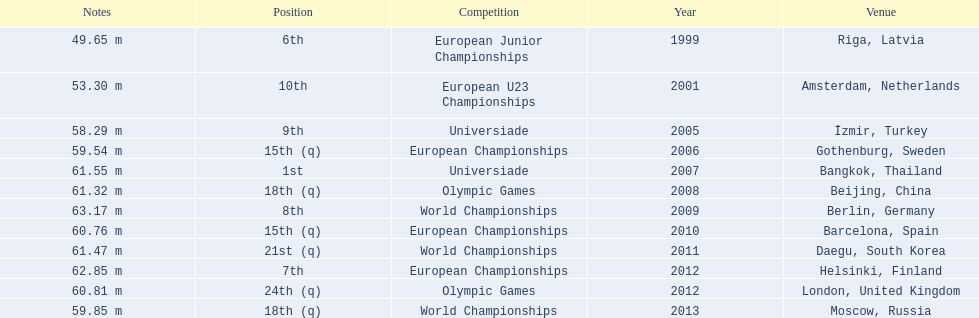What were the distances of mayer's throws? 49.65 m, 53.30 m, 58.29 m, 59.54 m, 61.55 m, 61.32 m, 63.17 m, 60.76 m, 61.47 m, 62.85 m, 60.81 m, 59.85 m. Which of these went the farthest? 63.17 m. 